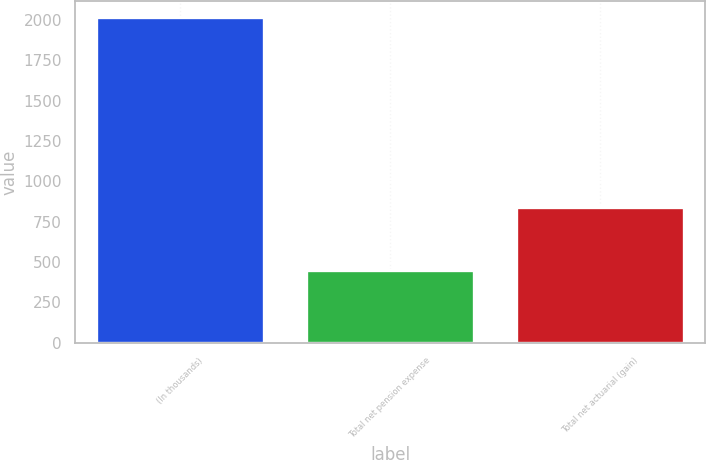Convert chart to OTSL. <chart><loc_0><loc_0><loc_500><loc_500><bar_chart><fcel>(In thousands)<fcel>Total net pension expense<fcel>Total net actuarial (gain)<nl><fcel>2015<fcel>453<fcel>840<nl></chart> 